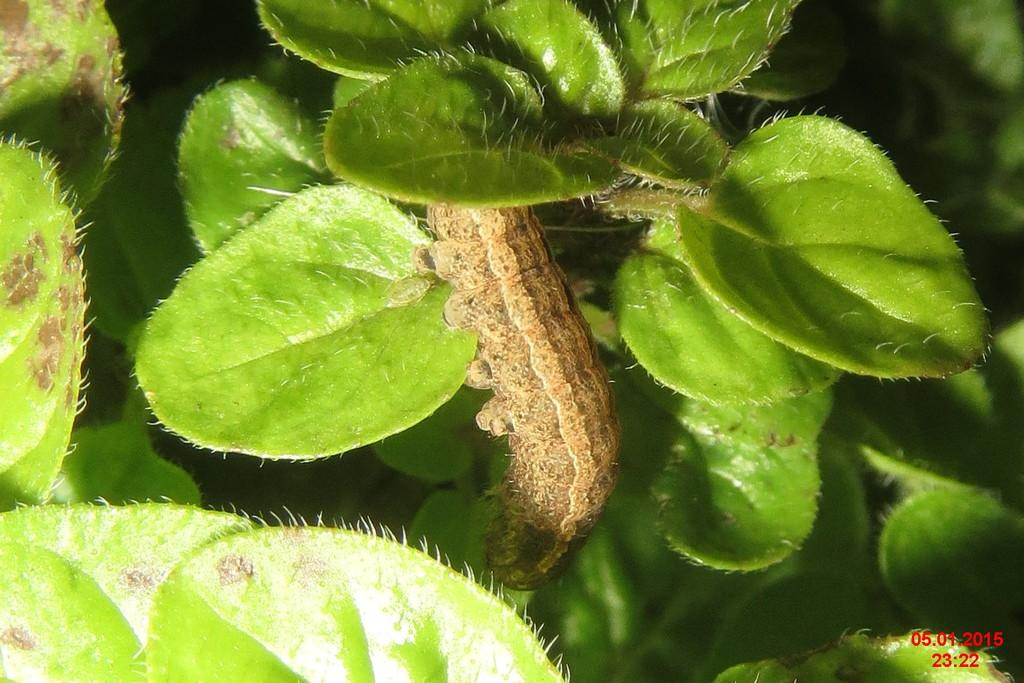What type of creature is in the image? There is a caterpillar in the image. What is the caterpillar interacting with in the image? The caterpillar is interacting with leaves in the image. Where are the numbers located in the image? The numbers are at the right bottom of the image. What type of crowd can be seen gathering around the caterpillar in the image? There is no crowd present in the image; it only features a caterpillar and leaves. What type of stocking is the caterpillar wearing in the image? The caterpillar is not wearing any stockings in the image. 